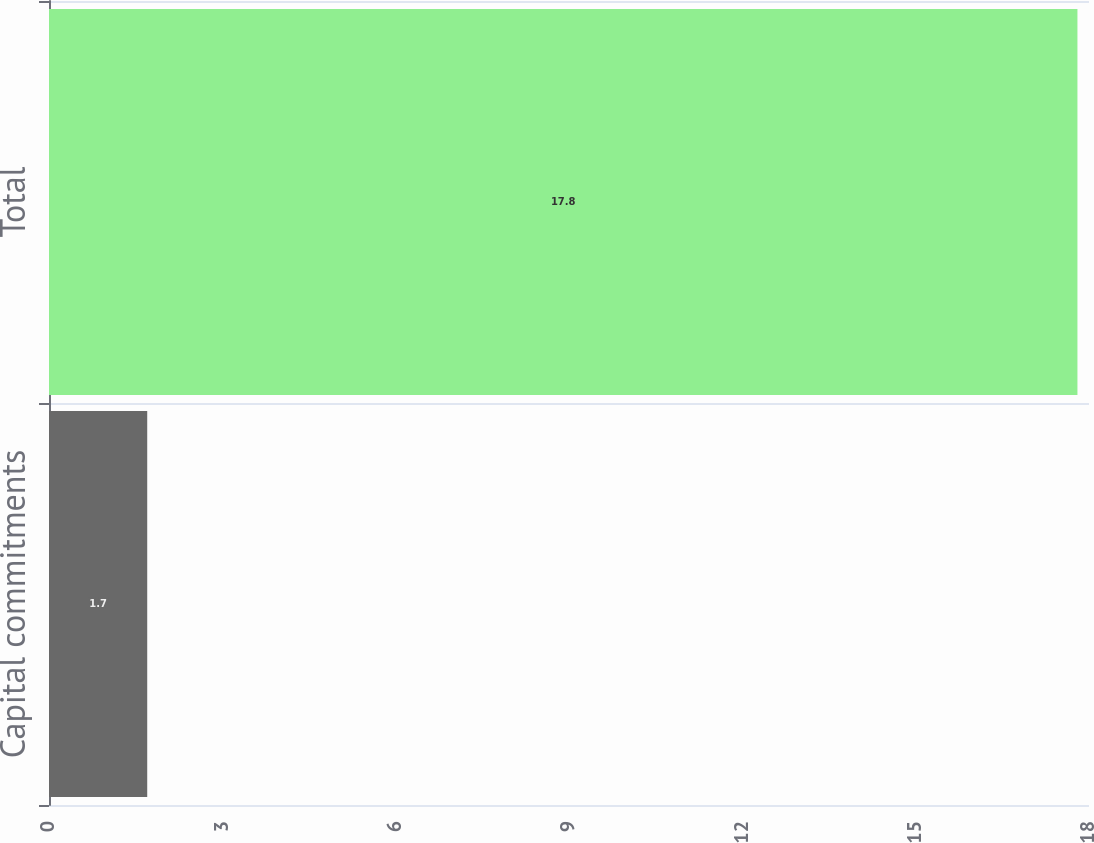Convert chart. <chart><loc_0><loc_0><loc_500><loc_500><bar_chart><fcel>Capital commitments<fcel>Total<nl><fcel>1.7<fcel>17.8<nl></chart> 